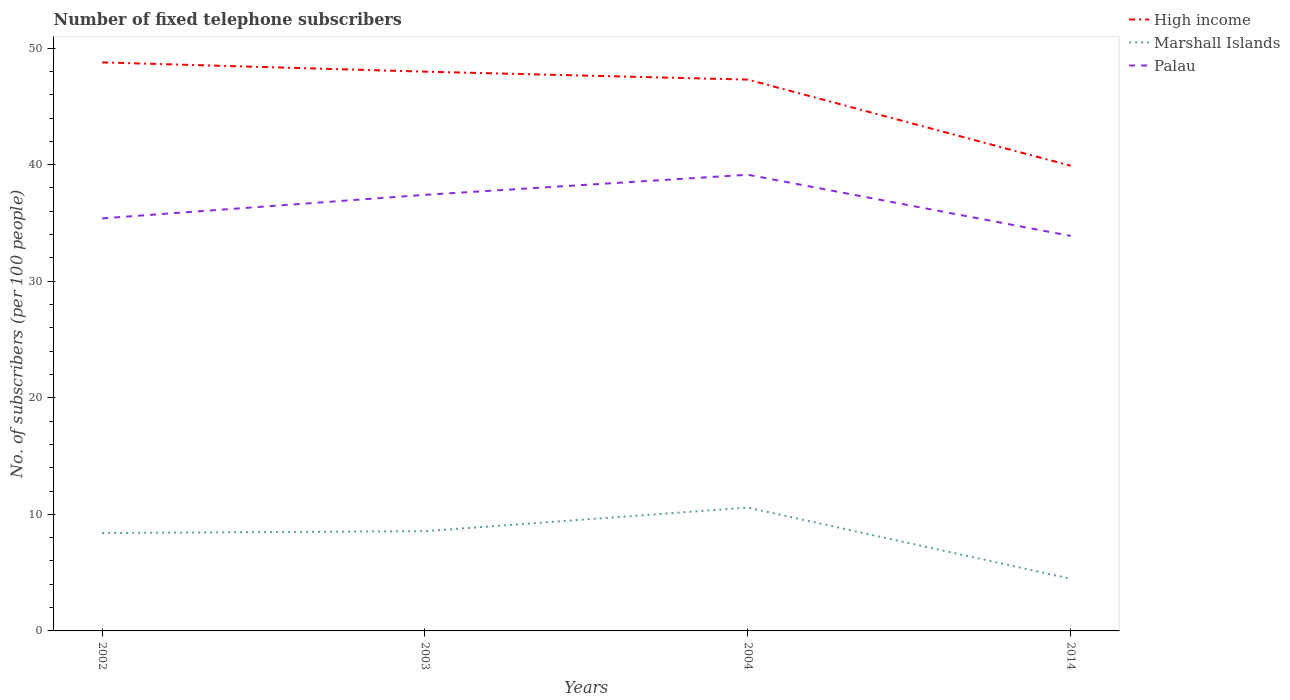Does the line corresponding to Marshall Islands intersect with the line corresponding to High income?
Provide a short and direct response. No. Across all years, what is the maximum number of fixed telephone subscribers in Palau?
Your answer should be compact. 33.89. In which year was the number of fixed telephone subscribers in Marshall Islands maximum?
Make the answer very short. 2014. What is the total number of fixed telephone subscribers in High income in the graph?
Give a very brief answer. 8.87. What is the difference between the highest and the second highest number of fixed telephone subscribers in Marshall Islands?
Offer a terse response. 6.11. How many lines are there?
Ensure brevity in your answer.  3. Where does the legend appear in the graph?
Make the answer very short. Top right. How are the legend labels stacked?
Provide a succinct answer. Vertical. What is the title of the graph?
Keep it short and to the point. Number of fixed telephone subscribers. What is the label or title of the X-axis?
Your answer should be compact. Years. What is the label or title of the Y-axis?
Your answer should be very brief. No. of subscribers (per 100 people). What is the No. of subscribers (per 100 people) in High income in 2002?
Ensure brevity in your answer.  48.77. What is the No. of subscribers (per 100 people) in Marshall Islands in 2002?
Offer a terse response. 8.4. What is the No. of subscribers (per 100 people) in Palau in 2002?
Offer a very short reply. 35.39. What is the No. of subscribers (per 100 people) in High income in 2003?
Your answer should be compact. 47.98. What is the No. of subscribers (per 100 people) in Marshall Islands in 2003?
Give a very brief answer. 8.56. What is the No. of subscribers (per 100 people) of Palau in 2003?
Make the answer very short. 37.41. What is the No. of subscribers (per 100 people) in High income in 2004?
Make the answer very short. 47.3. What is the No. of subscribers (per 100 people) in Marshall Islands in 2004?
Keep it short and to the point. 10.58. What is the No. of subscribers (per 100 people) in Palau in 2004?
Provide a short and direct response. 39.14. What is the No. of subscribers (per 100 people) of High income in 2014?
Keep it short and to the point. 39.9. What is the No. of subscribers (per 100 people) in Marshall Islands in 2014?
Give a very brief answer. 4.47. What is the No. of subscribers (per 100 people) in Palau in 2014?
Provide a succinct answer. 33.89. Across all years, what is the maximum No. of subscribers (per 100 people) in High income?
Provide a short and direct response. 48.77. Across all years, what is the maximum No. of subscribers (per 100 people) of Marshall Islands?
Provide a succinct answer. 10.58. Across all years, what is the maximum No. of subscribers (per 100 people) of Palau?
Offer a very short reply. 39.14. Across all years, what is the minimum No. of subscribers (per 100 people) of High income?
Provide a succinct answer. 39.9. Across all years, what is the minimum No. of subscribers (per 100 people) of Marshall Islands?
Provide a succinct answer. 4.47. Across all years, what is the minimum No. of subscribers (per 100 people) of Palau?
Offer a terse response. 33.89. What is the total No. of subscribers (per 100 people) in High income in the graph?
Give a very brief answer. 183.95. What is the total No. of subscribers (per 100 people) of Marshall Islands in the graph?
Offer a terse response. 32.01. What is the total No. of subscribers (per 100 people) in Palau in the graph?
Give a very brief answer. 145.83. What is the difference between the No. of subscribers (per 100 people) of High income in 2002 and that in 2003?
Your response must be concise. 0.8. What is the difference between the No. of subscribers (per 100 people) in Marshall Islands in 2002 and that in 2003?
Your response must be concise. -0.16. What is the difference between the No. of subscribers (per 100 people) of Palau in 2002 and that in 2003?
Give a very brief answer. -2.02. What is the difference between the No. of subscribers (per 100 people) in High income in 2002 and that in 2004?
Give a very brief answer. 1.48. What is the difference between the No. of subscribers (per 100 people) in Marshall Islands in 2002 and that in 2004?
Provide a succinct answer. -2.19. What is the difference between the No. of subscribers (per 100 people) of Palau in 2002 and that in 2004?
Your answer should be compact. -3.74. What is the difference between the No. of subscribers (per 100 people) of High income in 2002 and that in 2014?
Offer a terse response. 8.87. What is the difference between the No. of subscribers (per 100 people) in Marshall Islands in 2002 and that in 2014?
Give a very brief answer. 3.92. What is the difference between the No. of subscribers (per 100 people) of Palau in 2002 and that in 2014?
Offer a very short reply. 1.51. What is the difference between the No. of subscribers (per 100 people) in High income in 2003 and that in 2004?
Provide a succinct answer. 0.68. What is the difference between the No. of subscribers (per 100 people) of Marshall Islands in 2003 and that in 2004?
Your answer should be compact. -2.02. What is the difference between the No. of subscribers (per 100 people) of Palau in 2003 and that in 2004?
Ensure brevity in your answer.  -1.73. What is the difference between the No. of subscribers (per 100 people) of High income in 2003 and that in 2014?
Your answer should be compact. 8.07. What is the difference between the No. of subscribers (per 100 people) in Marshall Islands in 2003 and that in 2014?
Give a very brief answer. 4.09. What is the difference between the No. of subscribers (per 100 people) of Palau in 2003 and that in 2014?
Make the answer very short. 3.52. What is the difference between the No. of subscribers (per 100 people) of High income in 2004 and that in 2014?
Your response must be concise. 7.39. What is the difference between the No. of subscribers (per 100 people) of Marshall Islands in 2004 and that in 2014?
Offer a terse response. 6.11. What is the difference between the No. of subscribers (per 100 people) in Palau in 2004 and that in 2014?
Your response must be concise. 5.25. What is the difference between the No. of subscribers (per 100 people) in High income in 2002 and the No. of subscribers (per 100 people) in Marshall Islands in 2003?
Your answer should be compact. 40.21. What is the difference between the No. of subscribers (per 100 people) in High income in 2002 and the No. of subscribers (per 100 people) in Palau in 2003?
Your answer should be very brief. 11.36. What is the difference between the No. of subscribers (per 100 people) in Marshall Islands in 2002 and the No. of subscribers (per 100 people) in Palau in 2003?
Your answer should be compact. -29.02. What is the difference between the No. of subscribers (per 100 people) of High income in 2002 and the No. of subscribers (per 100 people) of Marshall Islands in 2004?
Make the answer very short. 38.19. What is the difference between the No. of subscribers (per 100 people) of High income in 2002 and the No. of subscribers (per 100 people) of Palau in 2004?
Make the answer very short. 9.64. What is the difference between the No. of subscribers (per 100 people) of Marshall Islands in 2002 and the No. of subscribers (per 100 people) of Palau in 2004?
Your response must be concise. -30.74. What is the difference between the No. of subscribers (per 100 people) in High income in 2002 and the No. of subscribers (per 100 people) in Marshall Islands in 2014?
Provide a succinct answer. 44.3. What is the difference between the No. of subscribers (per 100 people) of High income in 2002 and the No. of subscribers (per 100 people) of Palau in 2014?
Keep it short and to the point. 14.89. What is the difference between the No. of subscribers (per 100 people) of Marshall Islands in 2002 and the No. of subscribers (per 100 people) of Palau in 2014?
Offer a terse response. -25.49. What is the difference between the No. of subscribers (per 100 people) of High income in 2003 and the No. of subscribers (per 100 people) of Marshall Islands in 2004?
Keep it short and to the point. 37.4. What is the difference between the No. of subscribers (per 100 people) in High income in 2003 and the No. of subscribers (per 100 people) in Palau in 2004?
Keep it short and to the point. 8.84. What is the difference between the No. of subscribers (per 100 people) of Marshall Islands in 2003 and the No. of subscribers (per 100 people) of Palau in 2004?
Your response must be concise. -30.58. What is the difference between the No. of subscribers (per 100 people) of High income in 2003 and the No. of subscribers (per 100 people) of Marshall Islands in 2014?
Offer a very short reply. 43.5. What is the difference between the No. of subscribers (per 100 people) of High income in 2003 and the No. of subscribers (per 100 people) of Palau in 2014?
Offer a very short reply. 14.09. What is the difference between the No. of subscribers (per 100 people) of Marshall Islands in 2003 and the No. of subscribers (per 100 people) of Palau in 2014?
Your answer should be compact. -25.33. What is the difference between the No. of subscribers (per 100 people) in High income in 2004 and the No. of subscribers (per 100 people) in Marshall Islands in 2014?
Provide a succinct answer. 42.82. What is the difference between the No. of subscribers (per 100 people) of High income in 2004 and the No. of subscribers (per 100 people) of Palau in 2014?
Your answer should be very brief. 13.41. What is the difference between the No. of subscribers (per 100 people) in Marshall Islands in 2004 and the No. of subscribers (per 100 people) in Palau in 2014?
Give a very brief answer. -23.31. What is the average No. of subscribers (per 100 people) in High income per year?
Provide a short and direct response. 45.99. What is the average No. of subscribers (per 100 people) of Marshall Islands per year?
Ensure brevity in your answer.  8. What is the average No. of subscribers (per 100 people) in Palau per year?
Offer a terse response. 36.46. In the year 2002, what is the difference between the No. of subscribers (per 100 people) in High income and No. of subscribers (per 100 people) in Marshall Islands?
Your response must be concise. 40.38. In the year 2002, what is the difference between the No. of subscribers (per 100 people) of High income and No. of subscribers (per 100 people) of Palau?
Your response must be concise. 13.38. In the year 2002, what is the difference between the No. of subscribers (per 100 people) of Marshall Islands and No. of subscribers (per 100 people) of Palau?
Offer a terse response. -27. In the year 2003, what is the difference between the No. of subscribers (per 100 people) of High income and No. of subscribers (per 100 people) of Marshall Islands?
Ensure brevity in your answer.  39.42. In the year 2003, what is the difference between the No. of subscribers (per 100 people) of High income and No. of subscribers (per 100 people) of Palau?
Provide a short and direct response. 10.57. In the year 2003, what is the difference between the No. of subscribers (per 100 people) in Marshall Islands and No. of subscribers (per 100 people) in Palau?
Ensure brevity in your answer.  -28.85. In the year 2004, what is the difference between the No. of subscribers (per 100 people) in High income and No. of subscribers (per 100 people) in Marshall Islands?
Provide a short and direct response. 36.72. In the year 2004, what is the difference between the No. of subscribers (per 100 people) in High income and No. of subscribers (per 100 people) in Palau?
Your response must be concise. 8.16. In the year 2004, what is the difference between the No. of subscribers (per 100 people) of Marshall Islands and No. of subscribers (per 100 people) of Palau?
Offer a terse response. -28.56. In the year 2014, what is the difference between the No. of subscribers (per 100 people) in High income and No. of subscribers (per 100 people) in Marshall Islands?
Provide a short and direct response. 35.43. In the year 2014, what is the difference between the No. of subscribers (per 100 people) of High income and No. of subscribers (per 100 people) of Palau?
Your answer should be compact. 6.02. In the year 2014, what is the difference between the No. of subscribers (per 100 people) in Marshall Islands and No. of subscribers (per 100 people) in Palau?
Keep it short and to the point. -29.41. What is the ratio of the No. of subscribers (per 100 people) of High income in 2002 to that in 2003?
Offer a terse response. 1.02. What is the ratio of the No. of subscribers (per 100 people) in Marshall Islands in 2002 to that in 2003?
Provide a succinct answer. 0.98. What is the ratio of the No. of subscribers (per 100 people) in Palau in 2002 to that in 2003?
Your answer should be compact. 0.95. What is the ratio of the No. of subscribers (per 100 people) of High income in 2002 to that in 2004?
Offer a very short reply. 1.03. What is the ratio of the No. of subscribers (per 100 people) of Marshall Islands in 2002 to that in 2004?
Your response must be concise. 0.79. What is the ratio of the No. of subscribers (per 100 people) of Palau in 2002 to that in 2004?
Make the answer very short. 0.9. What is the ratio of the No. of subscribers (per 100 people) in High income in 2002 to that in 2014?
Your answer should be compact. 1.22. What is the ratio of the No. of subscribers (per 100 people) in Marshall Islands in 2002 to that in 2014?
Give a very brief answer. 1.88. What is the ratio of the No. of subscribers (per 100 people) in Palau in 2002 to that in 2014?
Offer a very short reply. 1.04. What is the ratio of the No. of subscribers (per 100 people) of High income in 2003 to that in 2004?
Ensure brevity in your answer.  1.01. What is the ratio of the No. of subscribers (per 100 people) in Marshall Islands in 2003 to that in 2004?
Your response must be concise. 0.81. What is the ratio of the No. of subscribers (per 100 people) of Palau in 2003 to that in 2004?
Keep it short and to the point. 0.96. What is the ratio of the No. of subscribers (per 100 people) of High income in 2003 to that in 2014?
Keep it short and to the point. 1.2. What is the ratio of the No. of subscribers (per 100 people) in Marshall Islands in 2003 to that in 2014?
Your answer should be very brief. 1.91. What is the ratio of the No. of subscribers (per 100 people) in Palau in 2003 to that in 2014?
Offer a terse response. 1.1. What is the ratio of the No. of subscribers (per 100 people) of High income in 2004 to that in 2014?
Give a very brief answer. 1.19. What is the ratio of the No. of subscribers (per 100 people) in Marshall Islands in 2004 to that in 2014?
Keep it short and to the point. 2.37. What is the ratio of the No. of subscribers (per 100 people) of Palau in 2004 to that in 2014?
Offer a very short reply. 1.15. What is the difference between the highest and the second highest No. of subscribers (per 100 people) in High income?
Your answer should be very brief. 0.8. What is the difference between the highest and the second highest No. of subscribers (per 100 people) of Marshall Islands?
Your response must be concise. 2.02. What is the difference between the highest and the second highest No. of subscribers (per 100 people) in Palau?
Give a very brief answer. 1.73. What is the difference between the highest and the lowest No. of subscribers (per 100 people) of High income?
Offer a very short reply. 8.87. What is the difference between the highest and the lowest No. of subscribers (per 100 people) in Marshall Islands?
Make the answer very short. 6.11. What is the difference between the highest and the lowest No. of subscribers (per 100 people) of Palau?
Your response must be concise. 5.25. 